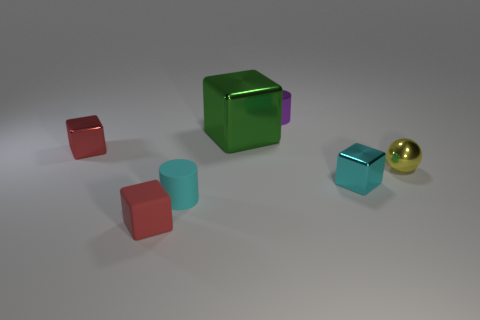Do the purple metal cylinder and the green metal cube have the same size?
Offer a very short reply. No. How many metal things are either yellow objects or big purple balls?
Give a very brief answer. 1. There is a yellow sphere that is the same size as the matte cylinder; what material is it?
Provide a succinct answer. Metal. What number of other objects are the same material as the cyan cylinder?
Your answer should be very brief. 1. Is the number of tiny cyan rubber cylinders behind the tiny red shiny thing less than the number of large green blocks?
Give a very brief answer. Yes. Do the tiny cyan metallic object and the big thing have the same shape?
Your answer should be very brief. Yes. What is the size of the green block that is behind the object that is on the right side of the cyan object that is to the right of the big green metal object?
Ensure brevity in your answer.  Large. What is the material of the other red object that is the same shape as the red matte thing?
Offer a very short reply. Metal. Is there anything else that is the same size as the green shiny cube?
Provide a succinct answer. No. What size is the red block to the right of the tiny red object that is on the left side of the red matte block?
Your answer should be very brief. Small. 